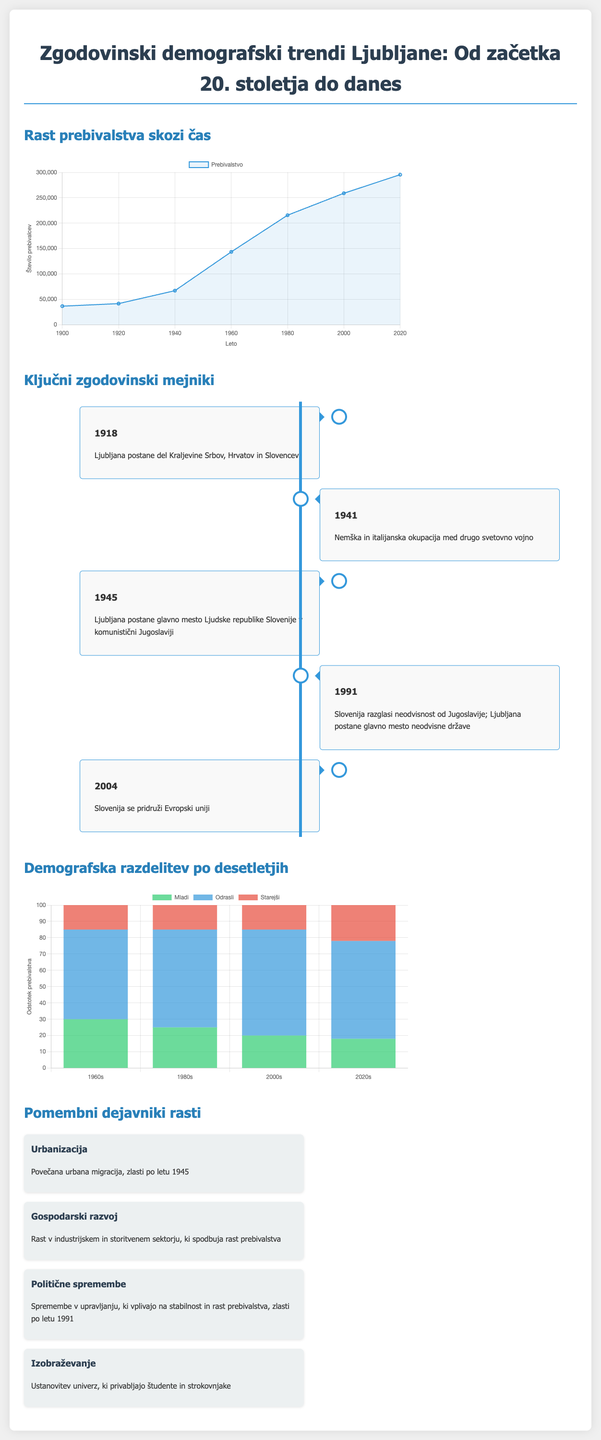what was the population of Ljubljana in 1900? The population in 1900 is indicated in the chart as 36479.
Answer: 36479 what year did Ljubljana become the capital of the People's Republic of Slovenia? According to the timeline, Ljubljana became the capital in 1945.
Answer: 1945 which year marks Slovenia's independence from Yugoslavia? The infographic states Slovenia declared independence in 1991.
Answer: 1991 what percentage of the population were adults in the 1980s? The demographic chart indicates that 60% of the population were adults in the 1980s.
Answer: 60% which key factor is associated with increased urban migration after 1945? The document attributes urban migration primarily to urbanization.
Answer: Urbanizacija what is the total population of Ljubljana in 2020? The chart shows the population of Ljubljana in 2020 as 295504.
Answer: 295504 how many historical milestones are listed in the timeline? The timeline features five key historical milestones.
Answer: 5 what demographic percentage of elderly people is shown for the 2020s? The demographic chart shows that elderly people made up 22% of the population in the 2020s.
Answer: 22% what is the primary economic factor influencing population growth? The infographic mentions economic development as the primary factor influencing growth.
Answer: Gospodarski razvoj 